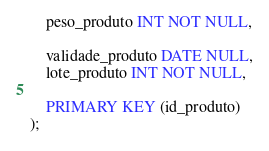<code> <loc_0><loc_0><loc_500><loc_500><_SQL_>    peso_produto INT NOT NULL,

    validade_produto DATE NULL,
    lote_produto INT NOT NULL,

    PRIMARY KEY (id_produto)
);


</code> 